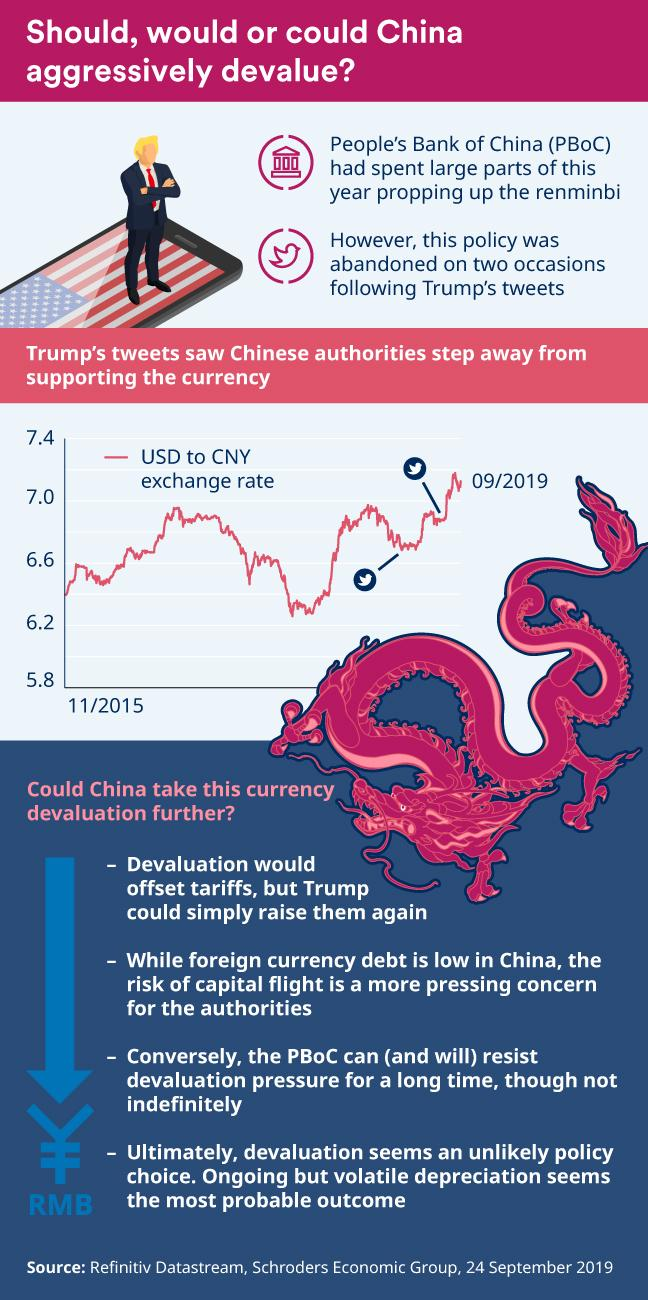Specify some key components in this picture. There are four points under the heading "Could China Take This Currency Devaluation Further?". 